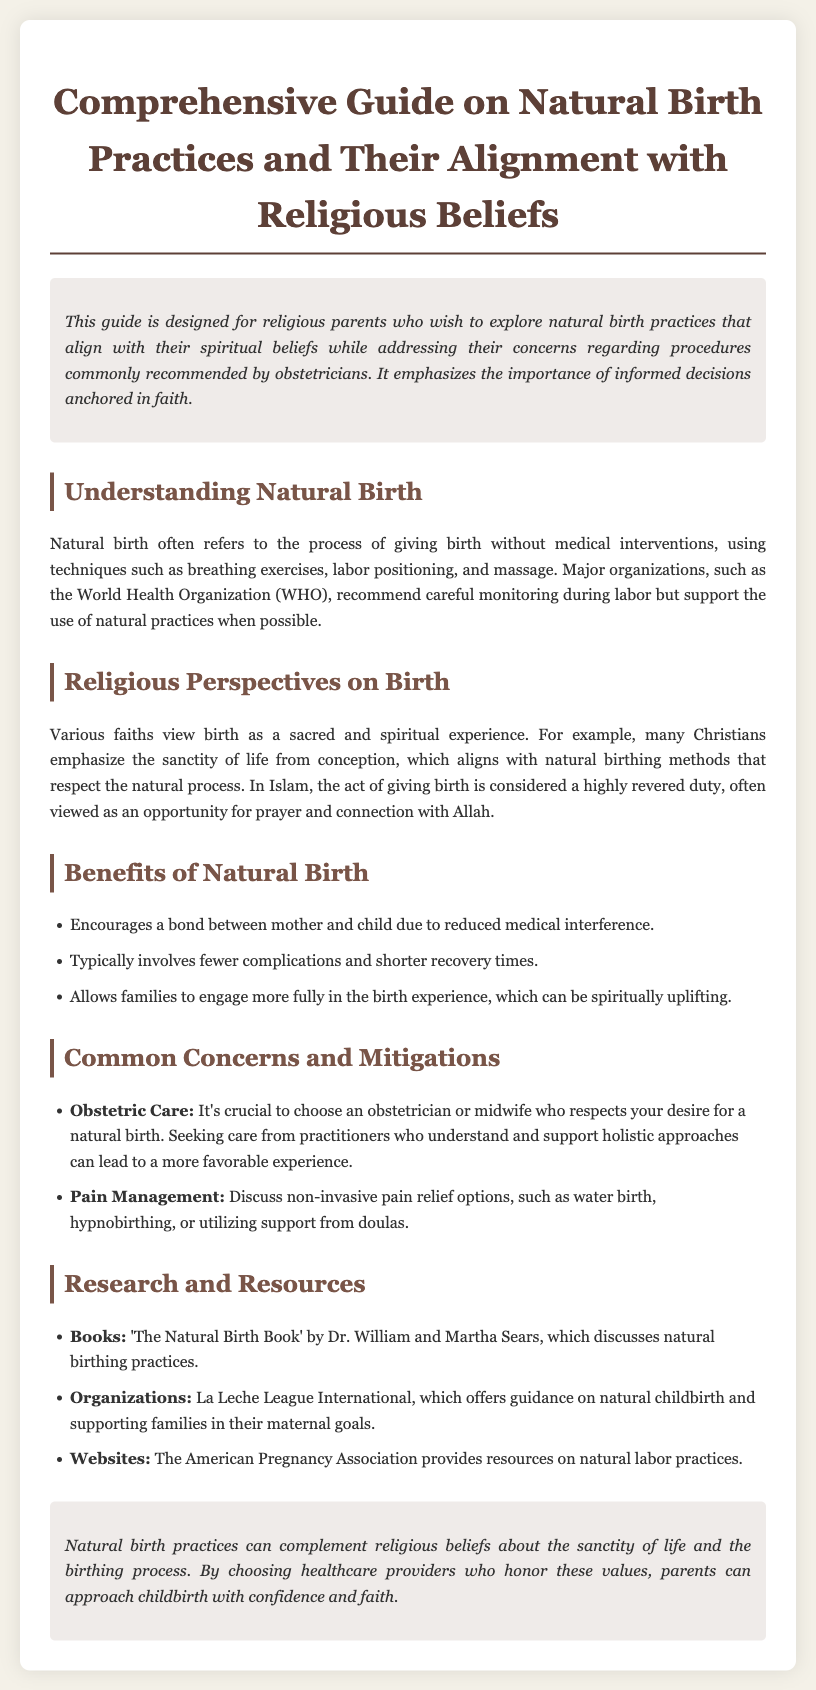What is the main purpose of the guide? The guide is designed for religious parents who wish to explore natural birth practices that align with their spiritual beliefs while addressing their concerns regarding procedures commonly recommended by obstetricians.
Answer: Exploring natural birth practices Which major organization supports natural practices during labor? The document mentions that major organizations, such as the World Health Organization (WHO), recommend careful monitoring during labor but support the use of natural practices.
Answer: World Health Organization What is one religious perspective on birth mentioned? The document states that many Christians emphasize the sanctity of life from conception, which aligns with natural birthing methods that respect the natural process.
Answer: Sanctity of life Name one benefit of natural birth. The guide lists several benefits, one of which is that it encourages a bond between mother and child due to reduced medical interference.
Answer: Bond between mother and child How should parents choose an obstetrician for a natural birth? Parents are advised to choose an obstetrician or midwife who respects their desire for a natural birth.
Answer: Respect for desire What is a non-invasive pain relief option mentioned? The document suggests options like water birth, hypnobirthing, or utilizing support from doulas as non-invasive pain relief methods.
Answer: Water birth What is one resource listed for natural childbirth? The guide references 'The Natural Birth Book' by Dr. William and Martha Sears, which discusses natural birthing practices.
Answer: The Natural Birth Book What faith views giving birth as a highly revered duty? The document mentions that in Islam, the act of giving birth is considered a highly revered duty.
Answer: Islam 